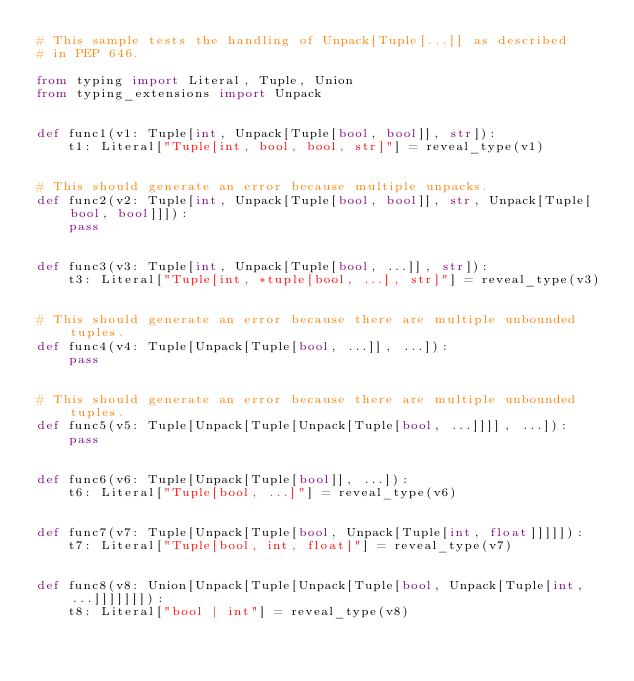Convert code to text. <code><loc_0><loc_0><loc_500><loc_500><_Python_># This sample tests the handling of Unpack[Tuple[...]] as described
# in PEP 646.

from typing import Literal, Tuple, Union
from typing_extensions import Unpack


def func1(v1: Tuple[int, Unpack[Tuple[bool, bool]], str]):
    t1: Literal["Tuple[int, bool, bool, str]"] = reveal_type(v1)


# This should generate an error because multiple unpacks.
def func2(v2: Tuple[int, Unpack[Tuple[bool, bool]], str, Unpack[Tuple[bool, bool]]]):
    pass


def func3(v3: Tuple[int, Unpack[Tuple[bool, ...]], str]):
    t3: Literal["Tuple[int, *tuple[bool, ...], str]"] = reveal_type(v3)


# This should generate an error because there are multiple unbounded tuples.
def func4(v4: Tuple[Unpack[Tuple[bool, ...]], ...]):
    pass


# This should generate an error because there are multiple unbounded tuples.
def func5(v5: Tuple[Unpack[Tuple[Unpack[Tuple[bool, ...]]]], ...]):
    pass


def func6(v6: Tuple[Unpack[Tuple[bool]], ...]):
    t6: Literal["Tuple[bool, ...]"] = reveal_type(v6)


def func7(v7: Tuple[Unpack[Tuple[bool, Unpack[Tuple[int, float]]]]]):
    t7: Literal["Tuple[bool, int, float]"] = reveal_type(v7)


def func8(v8: Union[Unpack[Tuple[Unpack[Tuple[bool, Unpack[Tuple[int, ...]]]]]]]):
    t8: Literal["bool | int"] = reveal_type(v8)
</code> 